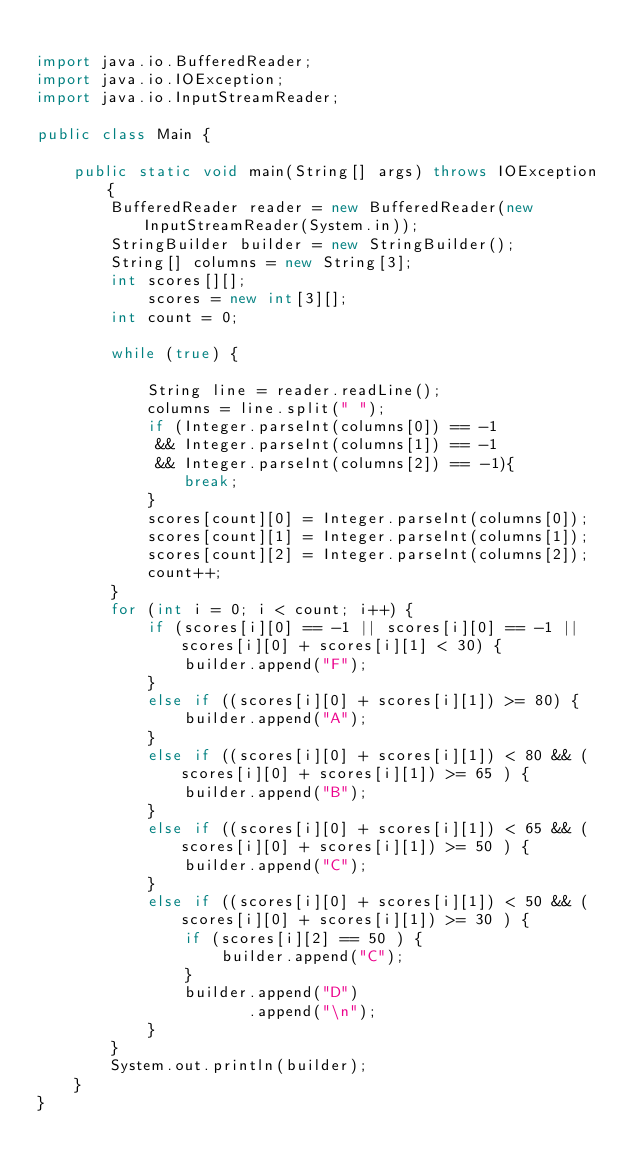Convert code to text. <code><loc_0><loc_0><loc_500><loc_500><_Java_>
import java.io.BufferedReader;
import java.io.IOException;
import java.io.InputStreamReader;

public class Main {

    public static void main(String[] args) throws IOException {
        BufferedReader reader = new BufferedReader(new InputStreamReader(System.in));
        StringBuilder builder = new StringBuilder();
        String[] columns = new String[3];
        int scores[][];
            scores = new int[3][];
        int count = 0;
        
        while (true) {

            String line = reader.readLine();
            columns = line.split(" ");
            if (Integer.parseInt(columns[0]) == -1 
             && Integer.parseInt(columns[1]) == -1
             && Integer.parseInt(columns[2]) == -1){
                break;
            }
            scores[count][0] = Integer.parseInt(columns[0]);
            scores[count][1] = Integer.parseInt(columns[1]);
            scores[count][2] = Integer.parseInt(columns[2]);
            count++;
        }
        for (int i = 0; i < count; i++) {
            if (scores[i][0] == -1 || scores[i][0] == -1 || scores[i][0] + scores[i][1] < 30) {
                builder.append("F");
            }
            else if ((scores[i][0] + scores[i][1]) >= 80) {
                builder.append("A");
            }
            else if ((scores[i][0] + scores[i][1]) < 80 && (scores[i][0] + scores[i][1]) >= 65 ) {
                builder.append("B");
            }
            else if ((scores[i][0] + scores[i][1]) < 65 && (scores[i][0] + scores[i][1]) >= 50 ) {
                builder.append("C");
            }
            else if ((scores[i][0] + scores[i][1]) < 50 && (scores[i][0] + scores[i][1]) >= 30 ) {
                if (scores[i][2] == 50 ) {
                    builder.append("C");
                }
                builder.append("D")
                       .append("\n");
            }
        }
        System.out.println(builder);
    }
}</code> 